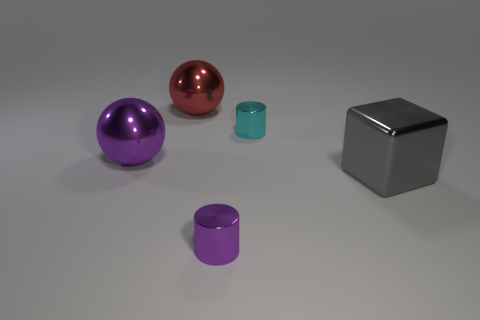What number of objects are tiny cyan cylinders or metal cylinders?
Provide a succinct answer. 2. Are there any other things that are the same shape as the gray shiny thing?
Your answer should be compact. No. There is a big gray object on the right side of the purple metal thing on the left side of the red shiny sphere; what is its shape?
Your answer should be very brief. Cube. What shape is the cyan thing that is made of the same material as the purple cylinder?
Make the answer very short. Cylinder. What is the size of the metallic ball to the right of the big shiny thing that is on the left side of the large red object?
Make the answer very short. Large. There is a red metal thing; what shape is it?
Offer a terse response. Sphere. What number of large things are either cyan things or rubber objects?
Provide a succinct answer. 0. There is a purple thing that is the same shape as the tiny cyan thing; what is its size?
Provide a short and direct response. Small. What number of objects are behind the large shiny cube and to the right of the small purple thing?
Give a very brief answer. 1. There is a tiny purple metallic object; is its shape the same as the small metal object that is behind the big gray shiny cube?
Your answer should be very brief. Yes. 